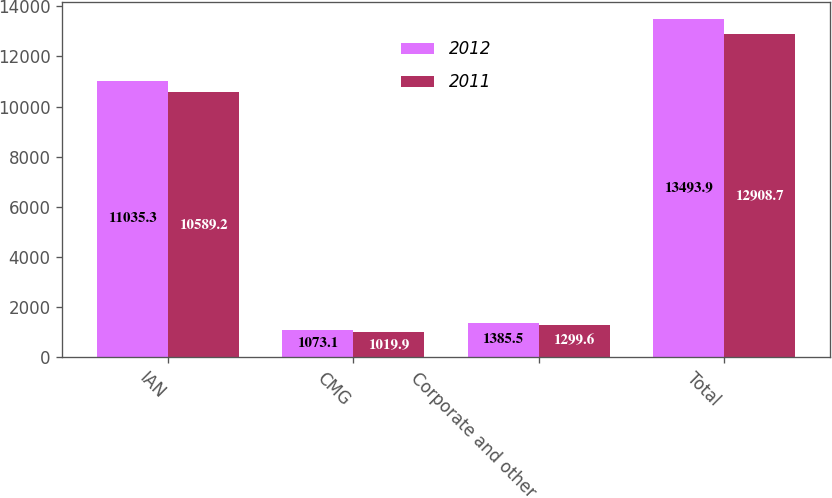Convert chart to OTSL. <chart><loc_0><loc_0><loc_500><loc_500><stacked_bar_chart><ecel><fcel>IAN<fcel>CMG<fcel>Corporate and other<fcel>Total<nl><fcel>2012<fcel>11035.3<fcel>1073.1<fcel>1385.5<fcel>13493.9<nl><fcel>2011<fcel>10589.2<fcel>1019.9<fcel>1299.6<fcel>12908.7<nl></chart> 